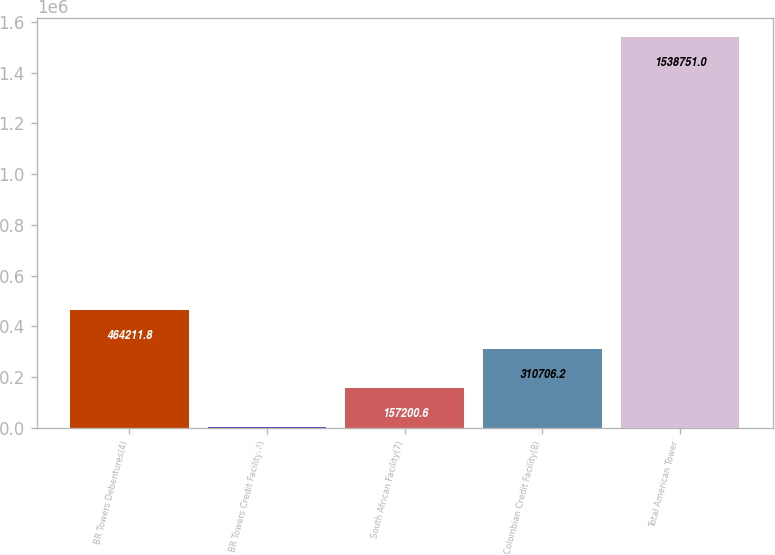<chart> <loc_0><loc_0><loc_500><loc_500><bar_chart><fcel>BR Towers Debentures(4)<fcel>BR Towers Credit Facility(4)<fcel>South African Facility(7)<fcel>Colombian Credit Facility(8)<fcel>Total American Tower<nl><fcel>464212<fcel>3695<fcel>157201<fcel>310706<fcel>1.53875e+06<nl></chart> 